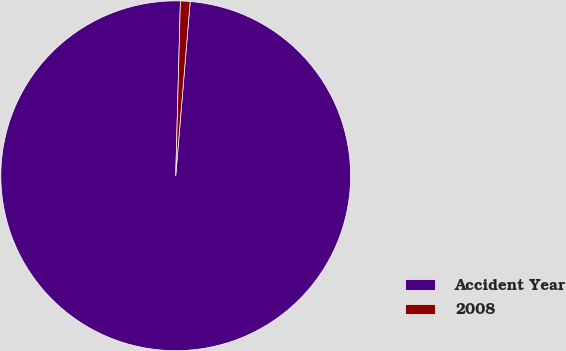Convert chart to OTSL. <chart><loc_0><loc_0><loc_500><loc_500><pie_chart><fcel>Accident Year<fcel>2008<nl><fcel>99.11%<fcel>0.89%<nl></chart> 